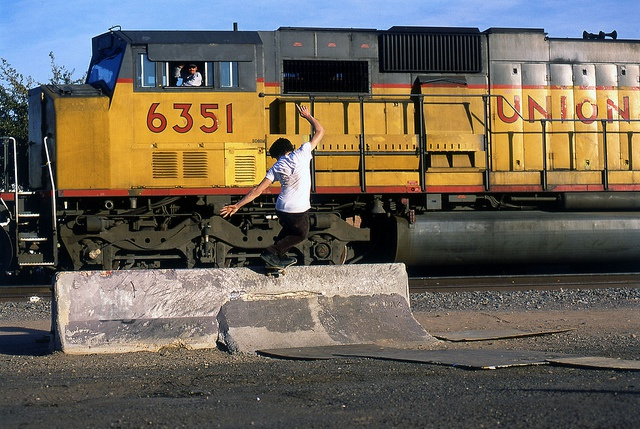Describe the objects in this image and their specific colors. I can see train in lightblue, black, gray, and orange tones, people in lightblue, black, white, tan, and gray tones, people in lightblue, black, lightgray, darkgray, and gray tones, and skateboard in lightblue, black, gray, olive, and darkgray tones in this image. 